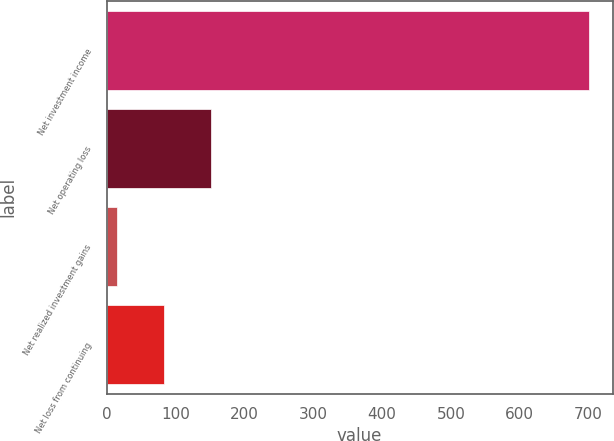Convert chart. <chart><loc_0><loc_0><loc_500><loc_500><bar_chart><fcel>Net investment income<fcel>Net operating loss<fcel>Net realized investment gains<fcel>Net loss from continuing<nl><fcel>700<fcel>152<fcel>15<fcel>83.5<nl></chart> 